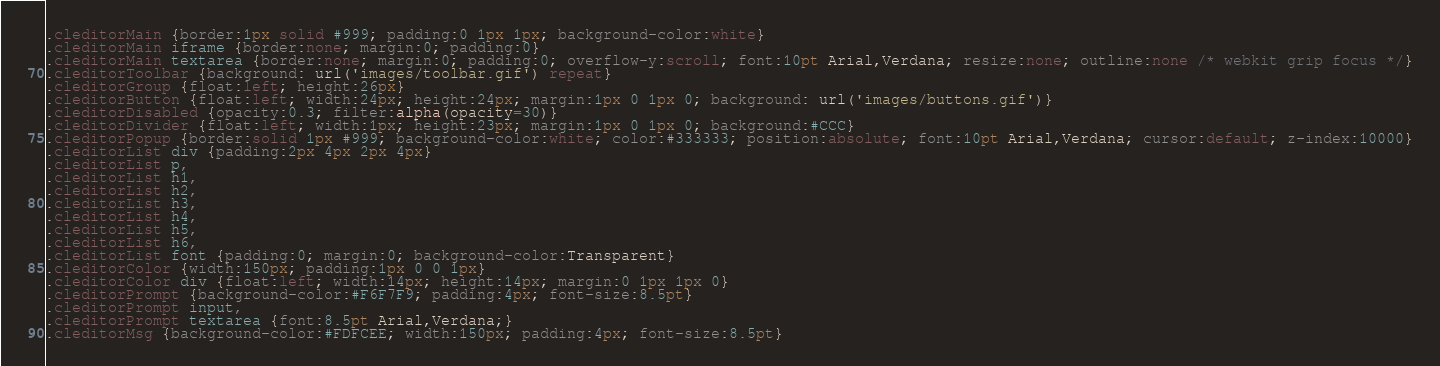Convert code to text. <code><loc_0><loc_0><loc_500><loc_500><_CSS_>.cleditorMain {border:1px solid #999; padding:0 1px 1px; background-color:white}
.cleditorMain iframe {border:none; margin:0; padding:0}
.cleditorMain textarea {border:none; margin:0; padding:0; overflow-y:scroll; font:10pt Arial,Verdana; resize:none; outline:none /* webkit grip focus */}
.cleditorToolbar {background: url('images/toolbar.gif') repeat}
.cleditorGroup {float:left; height:26px}
.cleditorButton {float:left; width:24px; height:24px; margin:1px 0 1px 0; background: url('images/buttons.gif')}
.cleditorDisabled {opacity:0.3; filter:alpha(opacity=30)}
.cleditorDivider {float:left; width:1px; height:23px; margin:1px 0 1px 0; background:#CCC}
.cleditorPopup {border:solid 1px #999; background-color:white; color:#333333; position:absolute; font:10pt Arial,Verdana; cursor:default; z-index:10000}
.cleditorList div {padding:2px 4px 2px 4px}
.cleditorList p,
.cleditorList h1,
.cleditorList h2,
.cleditorList h3,
.cleditorList h4,
.cleditorList h5,
.cleditorList h6,
.cleditorList font {padding:0; margin:0; background-color:Transparent}
.cleditorColor {width:150px; padding:1px 0 0 1px}
.cleditorColor div {float:left; width:14px; height:14px; margin:0 1px 1px 0}
.cleditorPrompt {background-color:#F6F7F9; padding:4px; font-size:8.5pt}
.cleditorPrompt input,
.cleditorPrompt textarea {font:8.5pt Arial,Verdana;}
.cleditorMsg {background-color:#FDFCEE; width:150px; padding:4px; font-size:8.5pt}
</code> 